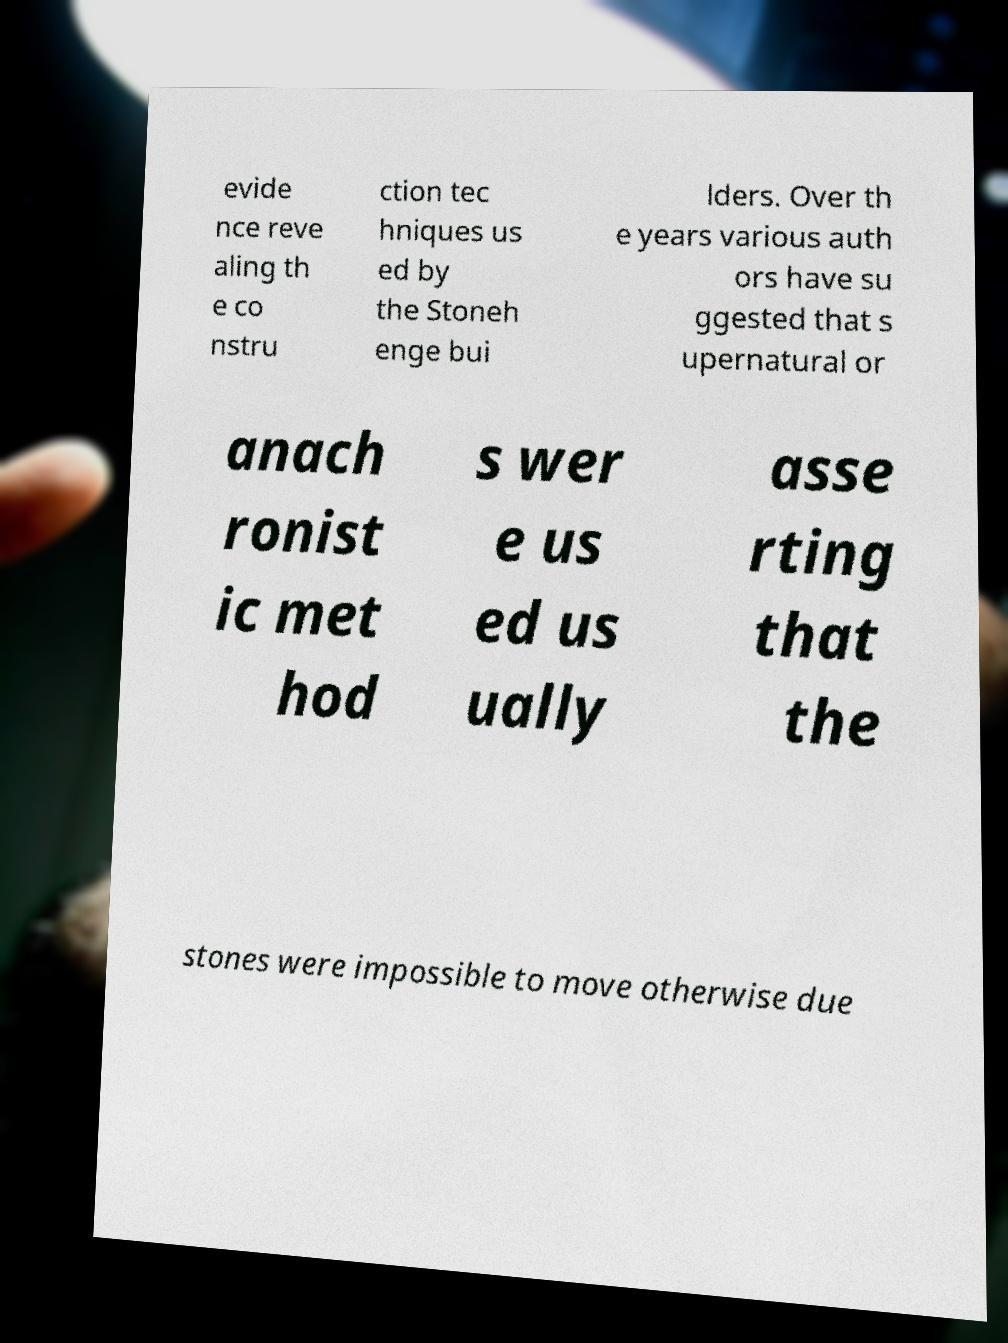What messages or text are displayed in this image? I need them in a readable, typed format. evide nce reve aling th e co nstru ction tec hniques us ed by the Stoneh enge bui lders. Over th e years various auth ors have su ggested that s upernatural or anach ronist ic met hod s wer e us ed us ually asse rting that the stones were impossible to move otherwise due 